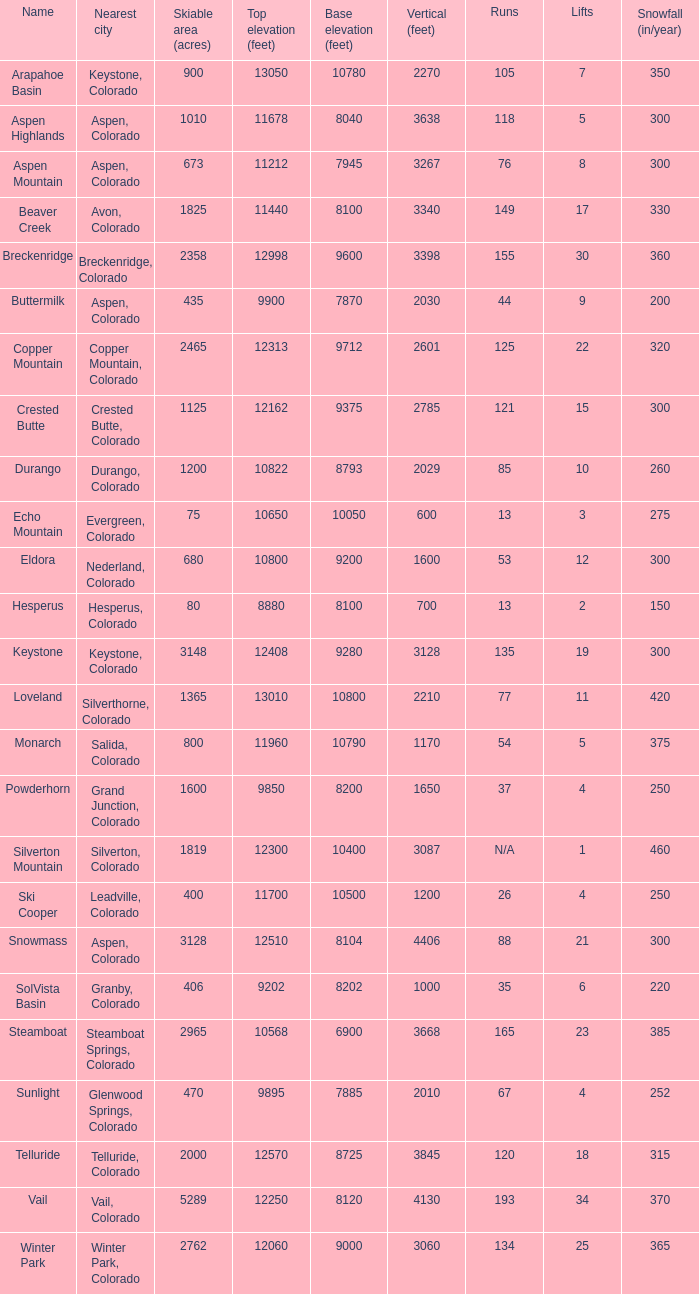If there are 11 lifts, what is the base elevation? 10800.0. 